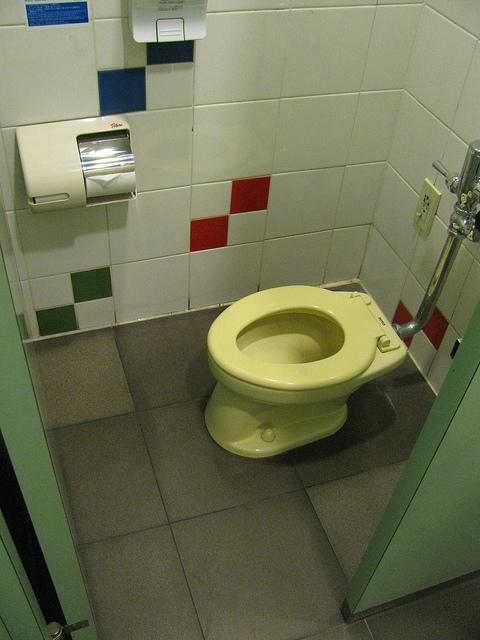Is this a public bathroom?
Quick response, please. Yes. Is this a typical flush toilet?
Quick response, please. Yes. Is the toilet seat up?
Keep it brief. No. What color is this toilet?
Be succinct. Yellow. 